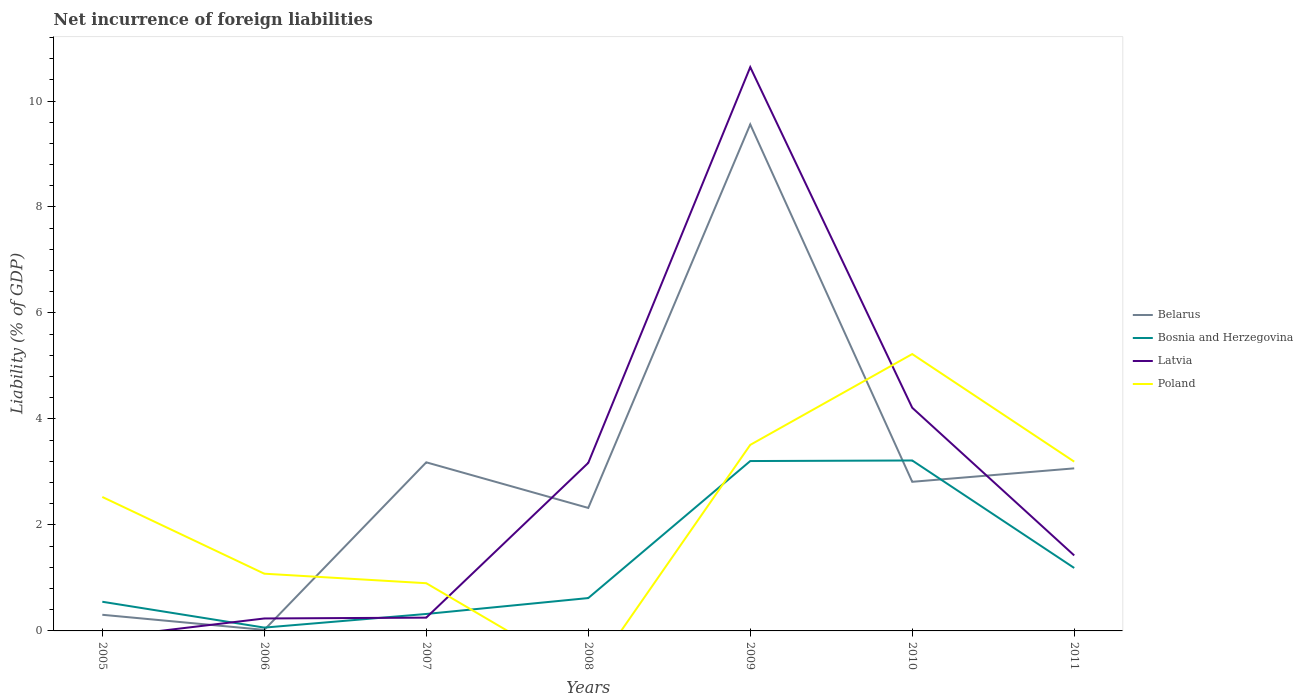How many different coloured lines are there?
Your answer should be compact. 4. Is the number of lines equal to the number of legend labels?
Keep it short and to the point. No. What is the total net incurrence of foreign liabilities in Poland in the graph?
Give a very brief answer. -0.98. What is the difference between the highest and the second highest net incurrence of foreign liabilities in Bosnia and Herzegovina?
Your response must be concise. 3.15. What is the difference between the highest and the lowest net incurrence of foreign liabilities in Poland?
Make the answer very short. 4. How many lines are there?
Provide a succinct answer. 4. What is the difference between two consecutive major ticks on the Y-axis?
Offer a very short reply. 2. Does the graph contain any zero values?
Provide a short and direct response. Yes. Where does the legend appear in the graph?
Your answer should be compact. Center right. How many legend labels are there?
Provide a short and direct response. 4. How are the legend labels stacked?
Your answer should be very brief. Vertical. What is the title of the graph?
Offer a very short reply. Net incurrence of foreign liabilities. What is the label or title of the X-axis?
Keep it short and to the point. Years. What is the label or title of the Y-axis?
Provide a succinct answer. Liability (% of GDP). What is the Liability (% of GDP) of Belarus in 2005?
Ensure brevity in your answer.  0.3. What is the Liability (% of GDP) in Bosnia and Herzegovina in 2005?
Your answer should be compact. 0.55. What is the Liability (% of GDP) in Latvia in 2005?
Your answer should be compact. 0. What is the Liability (% of GDP) in Poland in 2005?
Offer a very short reply. 2.53. What is the Liability (% of GDP) of Belarus in 2006?
Ensure brevity in your answer.  0.02. What is the Liability (% of GDP) in Bosnia and Herzegovina in 2006?
Your answer should be compact. 0.06. What is the Liability (% of GDP) in Latvia in 2006?
Your answer should be very brief. 0.23. What is the Liability (% of GDP) of Poland in 2006?
Ensure brevity in your answer.  1.08. What is the Liability (% of GDP) in Belarus in 2007?
Make the answer very short. 3.18. What is the Liability (% of GDP) of Bosnia and Herzegovina in 2007?
Give a very brief answer. 0.32. What is the Liability (% of GDP) of Latvia in 2007?
Make the answer very short. 0.25. What is the Liability (% of GDP) of Poland in 2007?
Keep it short and to the point. 0.9. What is the Liability (% of GDP) of Belarus in 2008?
Your answer should be compact. 2.32. What is the Liability (% of GDP) of Bosnia and Herzegovina in 2008?
Provide a short and direct response. 0.62. What is the Liability (% of GDP) in Latvia in 2008?
Provide a succinct answer. 3.17. What is the Liability (% of GDP) in Poland in 2008?
Give a very brief answer. 0. What is the Liability (% of GDP) of Belarus in 2009?
Keep it short and to the point. 9.56. What is the Liability (% of GDP) of Bosnia and Herzegovina in 2009?
Offer a very short reply. 3.21. What is the Liability (% of GDP) of Latvia in 2009?
Keep it short and to the point. 10.64. What is the Liability (% of GDP) of Poland in 2009?
Provide a short and direct response. 3.51. What is the Liability (% of GDP) of Belarus in 2010?
Offer a very short reply. 2.81. What is the Liability (% of GDP) in Bosnia and Herzegovina in 2010?
Provide a succinct answer. 3.22. What is the Liability (% of GDP) of Latvia in 2010?
Keep it short and to the point. 4.21. What is the Liability (% of GDP) of Poland in 2010?
Ensure brevity in your answer.  5.22. What is the Liability (% of GDP) of Belarus in 2011?
Your answer should be very brief. 3.07. What is the Liability (% of GDP) in Bosnia and Herzegovina in 2011?
Provide a short and direct response. 1.19. What is the Liability (% of GDP) of Latvia in 2011?
Offer a very short reply. 1.42. What is the Liability (% of GDP) of Poland in 2011?
Keep it short and to the point. 3.19. Across all years, what is the maximum Liability (% of GDP) of Belarus?
Your response must be concise. 9.56. Across all years, what is the maximum Liability (% of GDP) in Bosnia and Herzegovina?
Your answer should be very brief. 3.22. Across all years, what is the maximum Liability (% of GDP) of Latvia?
Provide a short and direct response. 10.64. Across all years, what is the maximum Liability (% of GDP) in Poland?
Provide a succinct answer. 5.22. Across all years, what is the minimum Liability (% of GDP) of Belarus?
Make the answer very short. 0.02. Across all years, what is the minimum Liability (% of GDP) of Bosnia and Herzegovina?
Your response must be concise. 0.06. What is the total Liability (% of GDP) in Belarus in the graph?
Your response must be concise. 21.27. What is the total Liability (% of GDP) of Bosnia and Herzegovina in the graph?
Offer a terse response. 9.16. What is the total Liability (% of GDP) in Latvia in the graph?
Your answer should be compact. 19.93. What is the total Liability (% of GDP) in Poland in the graph?
Ensure brevity in your answer.  16.44. What is the difference between the Liability (% of GDP) in Belarus in 2005 and that in 2006?
Provide a succinct answer. 0.28. What is the difference between the Liability (% of GDP) in Bosnia and Herzegovina in 2005 and that in 2006?
Your answer should be compact. 0.49. What is the difference between the Liability (% of GDP) of Poland in 2005 and that in 2006?
Offer a terse response. 1.45. What is the difference between the Liability (% of GDP) in Belarus in 2005 and that in 2007?
Provide a succinct answer. -2.88. What is the difference between the Liability (% of GDP) in Bosnia and Herzegovina in 2005 and that in 2007?
Give a very brief answer. 0.23. What is the difference between the Liability (% of GDP) of Poland in 2005 and that in 2007?
Your answer should be compact. 1.63. What is the difference between the Liability (% of GDP) in Belarus in 2005 and that in 2008?
Offer a terse response. -2.02. What is the difference between the Liability (% of GDP) in Bosnia and Herzegovina in 2005 and that in 2008?
Your answer should be compact. -0.07. What is the difference between the Liability (% of GDP) of Belarus in 2005 and that in 2009?
Your answer should be compact. -9.25. What is the difference between the Liability (% of GDP) in Bosnia and Herzegovina in 2005 and that in 2009?
Your response must be concise. -2.66. What is the difference between the Liability (% of GDP) of Poland in 2005 and that in 2009?
Your answer should be very brief. -0.98. What is the difference between the Liability (% of GDP) of Belarus in 2005 and that in 2010?
Your answer should be compact. -2.51. What is the difference between the Liability (% of GDP) of Bosnia and Herzegovina in 2005 and that in 2010?
Offer a very short reply. -2.67. What is the difference between the Liability (% of GDP) of Poland in 2005 and that in 2010?
Your answer should be compact. -2.7. What is the difference between the Liability (% of GDP) of Belarus in 2005 and that in 2011?
Give a very brief answer. -2.76. What is the difference between the Liability (% of GDP) in Bosnia and Herzegovina in 2005 and that in 2011?
Offer a very short reply. -0.64. What is the difference between the Liability (% of GDP) of Poland in 2005 and that in 2011?
Keep it short and to the point. -0.67. What is the difference between the Liability (% of GDP) in Belarus in 2006 and that in 2007?
Your response must be concise. -3.16. What is the difference between the Liability (% of GDP) of Bosnia and Herzegovina in 2006 and that in 2007?
Provide a short and direct response. -0.26. What is the difference between the Liability (% of GDP) in Latvia in 2006 and that in 2007?
Keep it short and to the point. -0.02. What is the difference between the Liability (% of GDP) of Poland in 2006 and that in 2007?
Offer a terse response. 0.18. What is the difference between the Liability (% of GDP) of Belarus in 2006 and that in 2008?
Keep it short and to the point. -2.3. What is the difference between the Liability (% of GDP) in Bosnia and Herzegovina in 2006 and that in 2008?
Keep it short and to the point. -0.56. What is the difference between the Liability (% of GDP) of Latvia in 2006 and that in 2008?
Give a very brief answer. -2.94. What is the difference between the Liability (% of GDP) of Belarus in 2006 and that in 2009?
Provide a succinct answer. -9.54. What is the difference between the Liability (% of GDP) in Bosnia and Herzegovina in 2006 and that in 2009?
Give a very brief answer. -3.14. What is the difference between the Liability (% of GDP) of Latvia in 2006 and that in 2009?
Provide a short and direct response. -10.4. What is the difference between the Liability (% of GDP) of Poland in 2006 and that in 2009?
Ensure brevity in your answer.  -2.43. What is the difference between the Liability (% of GDP) in Belarus in 2006 and that in 2010?
Provide a succinct answer. -2.79. What is the difference between the Liability (% of GDP) in Bosnia and Herzegovina in 2006 and that in 2010?
Provide a succinct answer. -3.15. What is the difference between the Liability (% of GDP) of Latvia in 2006 and that in 2010?
Make the answer very short. -3.98. What is the difference between the Liability (% of GDP) in Poland in 2006 and that in 2010?
Your answer should be very brief. -4.14. What is the difference between the Liability (% of GDP) in Belarus in 2006 and that in 2011?
Your response must be concise. -3.05. What is the difference between the Liability (% of GDP) in Bosnia and Herzegovina in 2006 and that in 2011?
Your answer should be compact. -1.13. What is the difference between the Liability (% of GDP) of Latvia in 2006 and that in 2011?
Offer a terse response. -1.19. What is the difference between the Liability (% of GDP) in Poland in 2006 and that in 2011?
Offer a terse response. -2.11. What is the difference between the Liability (% of GDP) of Belarus in 2007 and that in 2008?
Provide a short and direct response. 0.86. What is the difference between the Liability (% of GDP) in Bosnia and Herzegovina in 2007 and that in 2008?
Your answer should be very brief. -0.3. What is the difference between the Liability (% of GDP) in Latvia in 2007 and that in 2008?
Your answer should be very brief. -2.92. What is the difference between the Liability (% of GDP) in Belarus in 2007 and that in 2009?
Make the answer very short. -6.38. What is the difference between the Liability (% of GDP) of Bosnia and Herzegovina in 2007 and that in 2009?
Offer a very short reply. -2.89. What is the difference between the Liability (% of GDP) in Latvia in 2007 and that in 2009?
Ensure brevity in your answer.  -10.39. What is the difference between the Liability (% of GDP) in Poland in 2007 and that in 2009?
Offer a terse response. -2.61. What is the difference between the Liability (% of GDP) of Belarus in 2007 and that in 2010?
Offer a terse response. 0.37. What is the difference between the Liability (% of GDP) in Bosnia and Herzegovina in 2007 and that in 2010?
Your answer should be compact. -2.9. What is the difference between the Liability (% of GDP) of Latvia in 2007 and that in 2010?
Keep it short and to the point. -3.96. What is the difference between the Liability (% of GDP) of Poland in 2007 and that in 2010?
Offer a very short reply. -4.32. What is the difference between the Liability (% of GDP) of Belarus in 2007 and that in 2011?
Ensure brevity in your answer.  0.11. What is the difference between the Liability (% of GDP) of Bosnia and Herzegovina in 2007 and that in 2011?
Ensure brevity in your answer.  -0.87. What is the difference between the Liability (% of GDP) in Latvia in 2007 and that in 2011?
Your answer should be very brief. -1.17. What is the difference between the Liability (% of GDP) of Poland in 2007 and that in 2011?
Provide a succinct answer. -2.29. What is the difference between the Liability (% of GDP) of Belarus in 2008 and that in 2009?
Provide a short and direct response. -7.24. What is the difference between the Liability (% of GDP) in Bosnia and Herzegovina in 2008 and that in 2009?
Offer a very short reply. -2.59. What is the difference between the Liability (% of GDP) of Latvia in 2008 and that in 2009?
Give a very brief answer. -7.47. What is the difference between the Liability (% of GDP) of Belarus in 2008 and that in 2010?
Offer a terse response. -0.49. What is the difference between the Liability (% of GDP) in Bosnia and Herzegovina in 2008 and that in 2010?
Make the answer very short. -2.6. What is the difference between the Liability (% of GDP) in Latvia in 2008 and that in 2010?
Your answer should be compact. -1.04. What is the difference between the Liability (% of GDP) of Belarus in 2008 and that in 2011?
Make the answer very short. -0.75. What is the difference between the Liability (% of GDP) of Bosnia and Herzegovina in 2008 and that in 2011?
Your answer should be compact. -0.57. What is the difference between the Liability (% of GDP) in Latvia in 2008 and that in 2011?
Offer a very short reply. 1.75. What is the difference between the Liability (% of GDP) in Belarus in 2009 and that in 2010?
Your answer should be compact. 6.74. What is the difference between the Liability (% of GDP) in Bosnia and Herzegovina in 2009 and that in 2010?
Your answer should be very brief. -0.01. What is the difference between the Liability (% of GDP) of Latvia in 2009 and that in 2010?
Provide a succinct answer. 6.43. What is the difference between the Liability (% of GDP) of Poland in 2009 and that in 2010?
Your response must be concise. -1.71. What is the difference between the Liability (% of GDP) in Belarus in 2009 and that in 2011?
Give a very brief answer. 6.49. What is the difference between the Liability (% of GDP) in Bosnia and Herzegovina in 2009 and that in 2011?
Keep it short and to the point. 2.02. What is the difference between the Liability (% of GDP) in Latvia in 2009 and that in 2011?
Provide a short and direct response. 9.21. What is the difference between the Liability (% of GDP) of Poland in 2009 and that in 2011?
Ensure brevity in your answer.  0.32. What is the difference between the Liability (% of GDP) of Belarus in 2010 and that in 2011?
Provide a succinct answer. -0.25. What is the difference between the Liability (% of GDP) in Bosnia and Herzegovina in 2010 and that in 2011?
Your response must be concise. 2.03. What is the difference between the Liability (% of GDP) in Latvia in 2010 and that in 2011?
Offer a terse response. 2.79. What is the difference between the Liability (% of GDP) of Poland in 2010 and that in 2011?
Your response must be concise. 2.03. What is the difference between the Liability (% of GDP) of Belarus in 2005 and the Liability (% of GDP) of Bosnia and Herzegovina in 2006?
Offer a terse response. 0.24. What is the difference between the Liability (% of GDP) of Belarus in 2005 and the Liability (% of GDP) of Latvia in 2006?
Keep it short and to the point. 0.07. What is the difference between the Liability (% of GDP) of Belarus in 2005 and the Liability (% of GDP) of Poland in 2006?
Offer a very short reply. -0.78. What is the difference between the Liability (% of GDP) of Bosnia and Herzegovina in 2005 and the Liability (% of GDP) of Latvia in 2006?
Provide a short and direct response. 0.32. What is the difference between the Liability (% of GDP) of Bosnia and Herzegovina in 2005 and the Liability (% of GDP) of Poland in 2006?
Your response must be concise. -0.53. What is the difference between the Liability (% of GDP) of Belarus in 2005 and the Liability (% of GDP) of Bosnia and Herzegovina in 2007?
Your response must be concise. -0.02. What is the difference between the Liability (% of GDP) of Belarus in 2005 and the Liability (% of GDP) of Latvia in 2007?
Your answer should be very brief. 0.05. What is the difference between the Liability (% of GDP) in Belarus in 2005 and the Liability (% of GDP) in Poland in 2007?
Ensure brevity in your answer.  -0.6. What is the difference between the Liability (% of GDP) in Bosnia and Herzegovina in 2005 and the Liability (% of GDP) in Latvia in 2007?
Make the answer very short. 0.3. What is the difference between the Liability (% of GDP) in Bosnia and Herzegovina in 2005 and the Liability (% of GDP) in Poland in 2007?
Your response must be concise. -0.35. What is the difference between the Liability (% of GDP) of Belarus in 2005 and the Liability (% of GDP) of Bosnia and Herzegovina in 2008?
Keep it short and to the point. -0.32. What is the difference between the Liability (% of GDP) of Belarus in 2005 and the Liability (% of GDP) of Latvia in 2008?
Keep it short and to the point. -2.87. What is the difference between the Liability (% of GDP) in Bosnia and Herzegovina in 2005 and the Liability (% of GDP) in Latvia in 2008?
Provide a succinct answer. -2.62. What is the difference between the Liability (% of GDP) of Belarus in 2005 and the Liability (% of GDP) of Bosnia and Herzegovina in 2009?
Your answer should be compact. -2.9. What is the difference between the Liability (% of GDP) of Belarus in 2005 and the Liability (% of GDP) of Latvia in 2009?
Give a very brief answer. -10.33. What is the difference between the Liability (% of GDP) of Belarus in 2005 and the Liability (% of GDP) of Poland in 2009?
Give a very brief answer. -3.21. What is the difference between the Liability (% of GDP) in Bosnia and Herzegovina in 2005 and the Liability (% of GDP) in Latvia in 2009?
Provide a succinct answer. -10.09. What is the difference between the Liability (% of GDP) in Bosnia and Herzegovina in 2005 and the Liability (% of GDP) in Poland in 2009?
Keep it short and to the point. -2.96. What is the difference between the Liability (% of GDP) of Belarus in 2005 and the Liability (% of GDP) of Bosnia and Herzegovina in 2010?
Ensure brevity in your answer.  -2.91. What is the difference between the Liability (% of GDP) of Belarus in 2005 and the Liability (% of GDP) of Latvia in 2010?
Offer a terse response. -3.91. What is the difference between the Liability (% of GDP) of Belarus in 2005 and the Liability (% of GDP) of Poland in 2010?
Provide a succinct answer. -4.92. What is the difference between the Liability (% of GDP) in Bosnia and Herzegovina in 2005 and the Liability (% of GDP) in Latvia in 2010?
Your response must be concise. -3.66. What is the difference between the Liability (% of GDP) of Bosnia and Herzegovina in 2005 and the Liability (% of GDP) of Poland in 2010?
Offer a very short reply. -4.67. What is the difference between the Liability (% of GDP) in Belarus in 2005 and the Liability (% of GDP) in Bosnia and Herzegovina in 2011?
Your response must be concise. -0.88. What is the difference between the Liability (% of GDP) in Belarus in 2005 and the Liability (% of GDP) in Latvia in 2011?
Provide a succinct answer. -1.12. What is the difference between the Liability (% of GDP) of Belarus in 2005 and the Liability (% of GDP) of Poland in 2011?
Provide a short and direct response. -2.89. What is the difference between the Liability (% of GDP) in Bosnia and Herzegovina in 2005 and the Liability (% of GDP) in Latvia in 2011?
Provide a succinct answer. -0.87. What is the difference between the Liability (% of GDP) in Bosnia and Herzegovina in 2005 and the Liability (% of GDP) in Poland in 2011?
Provide a succinct answer. -2.64. What is the difference between the Liability (% of GDP) of Belarus in 2006 and the Liability (% of GDP) of Bosnia and Herzegovina in 2007?
Provide a succinct answer. -0.3. What is the difference between the Liability (% of GDP) in Belarus in 2006 and the Liability (% of GDP) in Latvia in 2007?
Provide a succinct answer. -0.23. What is the difference between the Liability (% of GDP) of Belarus in 2006 and the Liability (% of GDP) of Poland in 2007?
Give a very brief answer. -0.88. What is the difference between the Liability (% of GDP) of Bosnia and Herzegovina in 2006 and the Liability (% of GDP) of Latvia in 2007?
Provide a succinct answer. -0.19. What is the difference between the Liability (% of GDP) in Bosnia and Herzegovina in 2006 and the Liability (% of GDP) in Poland in 2007?
Your response must be concise. -0.84. What is the difference between the Liability (% of GDP) in Latvia in 2006 and the Liability (% of GDP) in Poland in 2007?
Make the answer very short. -0.67. What is the difference between the Liability (% of GDP) in Belarus in 2006 and the Liability (% of GDP) in Bosnia and Herzegovina in 2008?
Keep it short and to the point. -0.6. What is the difference between the Liability (% of GDP) of Belarus in 2006 and the Liability (% of GDP) of Latvia in 2008?
Provide a short and direct response. -3.15. What is the difference between the Liability (% of GDP) of Bosnia and Herzegovina in 2006 and the Liability (% of GDP) of Latvia in 2008?
Provide a short and direct response. -3.11. What is the difference between the Liability (% of GDP) in Belarus in 2006 and the Liability (% of GDP) in Bosnia and Herzegovina in 2009?
Make the answer very short. -3.19. What is the difference between the Liability (% of GDP) in Belarus in 2006 and the Liability (% of GDP) in Latvia in 2009?
Provide a short and direct response. -10.62. What is the difference between the Liability (% of GDP) in Belarus in 2006 and the Liability (% of GDP) in Poland in 2009?
Offer a terse response. -3.49. What is the difference between the Liability (% of GDP) of Bosnia and Herzegovina in 2006 and the Liability (% of GDP) of Latvia in 2009?
Offer a very short reply. -10.58. What is the difference between the Liability (% of GDP) in Bosnia and Herzegovina in 2006 and the Liability (% of GDP) in Poland in 2009?
Give a very brief answer. -3.45. What is the difference between the Liability (% of GDP) in Latvia in 2006 and the Liability (% of GDP) in Poland in 2009?
Provide a short and direct response. -3.28. What is the difference between the Liability (% of GDP) of Belarus in 2006 and the Liability (% of GDP) of Bosnia and Herzegovina in 2010?
Ensure brevity in your answer.  -3.2. What is the difference between the Liability (% of GDP) in Belarus in 2006 and the Liability (% of GDP) in Latvia in 2010?
Your answer should be very brief. -4.19. What is the difference between the Liability (% of GDP) of Belarus in 2006 and the Liability (% of GDP) of Poland in 2010?
Offer a very short reply. -5.2. What is the difference between the Liability (% of GDP) of Bosnia and Herzegovina in 2006 and the Liability (% of GDP) of Latvia in 2010?
Your answer should be very brief. -4.15. What is the difference between the Liability (% of GDP) in Bosnia and Herzegovina in 2006 and the Liability (% of GDP) in Poland in 2010?
Provide a short and direct response. -5.16. What is the difference between the Liability (% of GDP) in Latvia in 2006 and the Liability (% of GDP) in Poland in 2010?
Make the answer very short. -4.99. What is the difference between the Liability (% of GDP) in Belarus in 2006 and the Liability (% of GDP) in Bosnia and Herzegovina in 2011?
Offer a very short reply. -1.17. What is the difference between the Liability (% of GDP) in Belarus in 2006 and the Liability (% of GDP) in Latvia in 2011?
Your answer should be very brief. -1.4. What is the difference between the Liability (% of GDP) in Belarus in 2006 and the Liability (% of GDP) in Poland in 2011?
Offer a terse response. -3.17. What is the difference between the Liability (% of GDP) in Bosnia and Herzegovina in 2006 and the Liability (% of GDP) in Latvia in 2011?
Your answer should be compact. -1.36. What is the difference between the Liability (% of GDP) of Bosnia and Herzegovina in 2006 and the Liability (% of GDP) of Poland in 2011?
Ensure brevity in your answer.  -3.13. What is the difference between the Liability (% of GDP) of Latvia in 2006 and the Liability (% of GDP) of Poland in 2011?
Offer a terse response. -2.96. What is the difference between the Liability (% of GDP) in Belarus in 2007 and the Liability (% of GDP) in Bosnia and Herzegovina in 2008?
Make the answer very short. 2.56. What is the difference between the Liability (% of GDP) in Belarus in 2007 and the Liability (% of GDP) in Latvia in 2008?
Offer a very short reply. 0.01. What is the difference between the Liability (% of GDP) of Bosnia and Herzegovina in 2007 and the Liability (% of GDP) of Latvia in 2008?
Give a very brief answer. -2.85. What is the difference between the Liability (% of GDP) in Belarus in 2007 and the Liability (% of GDP) in Bosnia and Herzegovina in 2009?
Provide a succinct answer. -0.02. What is the difference between the Liability (% of GDP) in Belarus in 2007 and the Liability (% of GDP) in Latvia in 2009?
Offer a terse response. -7.46. What is the difference between the Liability (% of GDP) in Belarus in 2007 and the Liability (% of GDP) in Poland in 2009?
Make the answer very short. -0.33. What is the difference between the Liability (% of GDP) in Bosnia and Herzegovina in 2007 and the Liability (% of GDP) in Latvia in 2009?
Give a very brief answer. -10.32. What is the difference between the Liability (% of GDP) in Bosnia and Herzegovina in 2007 and the Liability (% of GDP) in Poland in 2009?
Keep it short and to the point. -3.19. What is the difference between the Liability (% of GDP) of Latvia in 2007 and the Liability (% of GDP) of Poland in 2009?
Give a very brief answer. -3.26. What is the difference between the Liability (% of GDP) in Belarus in 2007 and the Liability (% of GDP) in Bosnia and Herzegovina in 2010?
Your answer should be compact. -0.03. What is the difference between the Liability (% of GDP) of Belarus in 2007 and the Liability (% of GDP) of Latvia in 2010?
Your answer should be very brief. -1.03. What is the difference between the Liability (% of GDP) in Belarus in 2007 and the Liability (% of GDP) in Poland in 2010?
Give a very brief answer. -2.04. What is the difference between the Liability (% of GDP) in Bosnia and Herzegovina in 2007 and the Liability (% of GDP) in Latvia in 2010?
Ensure brevity in your answer.  -3.89. What is the difference between the Liability (% of GDP) in Bosnia and Herzegovina in 2007 and the Liability (% of GDP) in Poland in 2010?
Your answer should be very brief. -4.9. What is the difference between the Liability (% of GDP) in Latvia in 2007 and the Liability (% of GDP) in Poland in 2010?
Provide a succinct answer. -4.97. What is the difference between the Liability (% of GDP) of Belarus in 2007 and the Liability (% of GDP) of Bosnia and Herzegovina in 2011?
Offer a very short reply. 1.99. What is the difference between the Liability (% of GDP) of Belarus in 2007 and the Liability (% of GDP) of Latvia in 2011?
Offer a terse response. 1.76. What is the difference between the Liability (% of GDP) of Belarus in 2007 and the Liability (% of GDP) of Poland in 2011?
Offer a terse response. -0.01. What is the difference between the Liability (% of GDP) of Bosnia and Herzegovina in 2007 and the Liability (% of GDP) of Latvia in 2011?
Your response must be concise. -1.1. What is the difference between the Liability (% of GDP) in Bosnia and Herzegovina in 2007 and the Liability (% of GDP) in Poland in 2011?
Offer a very short reply. -2.87. What is the difference between the Liability (% of GDP) of Latvia in 2007 and the Liability (% of GDP) of Poland in 2011?
Your response must be concise. -2.94. What is the difference between the Liability (% of GDP) of Belarus in 2008 and the Liability (% of GDP) of Bosnia and Herzegovina in 2009?
Provide a succinct answer. -0.88. What is the difference between the Liability (% of GDP) in Belarus in 2008 and the Liability (% of GDP) in Latvia in 2009?
Keep it short and to the point. -8.32. What is the difference between the Liability (% of GDP) of Belarus in 2008 and the Liability (% of GDP) of Poland in 2009?
Provide a short and direct response. -1.19. What is the difference between the Liability (% of GDP) in Bosnia and Herzegovina in 2008 and the Liability (% of GDP) in Latvia in 2009?
Provide a succinct answer. -10.02. What is the difference between the Liability (% of GDP) in Bosnia and Herzegovina in 2008 and the Liability (% of GDP) in Poland in 2009?
Provide a succinct answer. -2.89. What is the difference between the Liability (% of GDP) of Latvia in 2008 and the Liability (% of GDP) of Poland in 2009?
Your answer should be very brief. -0.34. What is the difference between the Liability (% of GDP) in Belarus in 2008 and the Liability (% of GDP) in Bosnia and Herzegovina in 2010?
Offer a very short reply. -0.9. What is the difference between the Liability (% of GDP) in Belarus in 2008 and the Liability (% of GDP) in Latvia in 2010?
Provide a succinct answer. -1.89. What is the difference between the Liability (% of GDP) in Belarus in 2008 and the Liability (% of GDP) in Poland in 2010?
Provide a short and direct response. -2.9. What is the difference between the Liability (% of GDP) in Bosnia and Herzegovina in 2008 and the Liability (% of GDP) in Latvia in 2010?
Ensure brevity in your answer.  -3.59. What is the difference between the Liability (% of GDP) in Bosnia and Herzegovina in 2008 and the Liability (% of GDP) in Poland in 2010?
Provide a short and direct response. -4.6. What is the difference between the Liability (% of GDP) of Latvia in 2008 and the Liability (% of GDP) of Poland in 2010?
Your answer should be compact. -2.05. What is the difference between the Liability (% of GDP) of Belarus in 2008 and the Liability (% of GDP) of Bosnia and Herzegovina in 2011?
Provide a succinct answer. 1.13. What is the difference between the Liability (% of GDP) of Belarus in 2008 and the Liability (% of GDP) of Latvia in 2011?
Your response must be concise. 0.9. What is the difference between the Liability (% of GDP) in Belarus in 2008 and the Liability (% of GDP) in Poland in 2011?
Provide a short and direct response. -0.87. What is the difference between the Liability (% of GDP) of Bosnia and Herzegovina in 2008 and the Liability (% of GDP) of Latvia in 2011?
Provide a succinct answer. -0.8. What is the difference between the Liability (% of GDP) of Bosnia and Herzegovina in 2008 and the Liability (% of GDP) of Poland in 2011?
Make the answer very short. -2.57. What is the difference between the Liability (% of GDP) in Latvia in 2008 and the Liability (% of GDP) in Poland in 2011?
Give a very brief answer. -0.02. What is the difference between the Liability (% of GDP) in Belarus in 2009 and the Liability (% of GDP) in Bosnia and Herzegovina in 2010?
Your response must be concise. 6.34. What is the difference between the Liability (% of GDP) of Belarus in 2009 and the Liability (% of GDP) of Latvia in 2010?
Make the answer very short. 5.35. What is the difference between the Liability (% of GDP) of Belarus in 2009 and the Liability (% of GDP) of Poland in 2010?
Your answer should be compact. 4.33. What is the difference between the Liability (% of GDP) in Bosnia and Herzegovina in 2009 and the Liability (% of GDP) in Latvia in 2010?
Make the answer very short. -1.01. What is the difference between the Liability (% of GDP) in Bosnia and Herzegovina in 2009 and the Liability (% of GDP) in Poland in 2010?
Give a very brief answer. -2.02. What is the difference between the Liability (% of GDP) in Latvia in 2009 and the Liability (% of GDP) in Poland in 2010?
Ensure brevity in your answer.  5.41. What is the difference between the Liability (% of GDP) in Belarus in 2009 and the Liability (% of GDP) in Bosnia and Herzegovina in 2011?
Offer a very short reply. 8.37. What is the difference between the Liability (% of GDP) in Belarus in 2009 and the Liability (% of GDP) in Latvia in 2011?
Provide a succinct answer. 8.13. What is the difference between the Liability (% of GDP) in Belarus in 2009 and the Liability (% of GDP) in Poland in 2011?
Your answer should be compact. 6.36. What is the difference between the Liability (% of GDP) of Bosnia and Herzegovina in 2009 and the Liability (% of GDP) of Latvia in 2011?
Your response must be concise. 1.78. What is the difference between the Liability (% of GDP) of Bosnia and Herzegovina in 2009 and the Liability (% of GDP) of Poland in 2011?
Your answer should be very brief. 0.01. What is the difference between the Liability (% of GDP) in Latvia in 2009 and the Liability (% of GDP) in Poland in 2011?
Provide a succinct answer. 7.45. What is the difference between the Liability (% of GDP) in Belarus in 2010 and the Liability (% of GDP) in Bosnia and Herzegovina in 2011?
Make the answer very short. 1.63. What is the difference between the Liability (% of GDP) in Belarus in 2010 and the Liability (% of GDP) in Latvia in 2011?
Ensure brevity in your answer.  1.39. What is the difference between the Liability (% of GDP) in Belarus in 2010 and the Liability (% of GDP) in Poland in 2011?
Ensure brevity in your answer.  -0.38. What is the difference between the Liability (% of GDP) in Bosnia and Herzegovina in 2010 and the Liability (% of GDP) in Latvia in 2011?
Ensure brevity in your answer.  1.79. What is the difference between the Liability (% of GDP) of Bosnia and Herzegovina in 2010 and the Liability (% of GDP) of Poland in 2011?
Ensure brevity in your answer.  0.02. What is the difference between the Liability (% of GDP) in Latvia in 2010 and the Liability (% of GDP) in Poland in 2011?
Offer a very short reply. 1.02. What is the average Liability (% of GDP) in Belarus per year?
Your response must be concise. 3.04. What is the average Liability (% of GDP) in Bosnia and Herzegovina per year?
Provide a short and direct response. 1.31. What is the average Liability (% of GDP) of Latvia per year?
Provide a succinct answer. 2.85. What is the average Liability (% of GDP) of Poland per year?
Provide a short and direct response. 2.35. In the year 2005, what is the difference between the Liability (% of GDP) in Belarus and Liability (% of GDP) in Bosnia and Herzegovina?
Make the answer very short. -0.25. In the year 2005, what is the difference between the Liability (% of GDP) of Belarus and Liability (% of GDP) of Poland?
Make the answer very short. -2.22. In the year 2005, what is the difference between the Liability (% of GDP) of Bosnia and Herzegovina and Liability (% of GDP) of Poland?
Offer a very short reply. -1.98. In the year 2006, what is the difference between the Liability (% of GDP) of Belarus and Liability (% of GDP) of Bosnia and Herzegovina?
Make the answer very short. -0.04. In the year 2006, what is the difference between the Liability (% of GDP) of Belarus and Liability (% of GDP) of Latvia?
Provide a succinct answer. -0.22. In the year 2006, what is the difference between the Liability (% of GDP) in Belarus and Liability (% of GDP) in Poland?
Your answer should be very brief. -1.06. In the year 2006, what is the difference between the Liability (% of GDP) of Bosnia and Herzegovina and Liability (% of GDP) of Latvia?
Ensure brevity in your answer.  -0.17. In the year 2006, what is the difference between the Liability (% of GDP) in Bosnia and Herzegovina and Liability (% of GDP) in Poland?
Your answer should be compact. -1.02. In the year 2006, what is the difference between the Liability (% of GDP) of Latvia and Liability (% of GDP) of Poland?
Your response must be concise. -0.84. In the year 2007, what is the difference between the Liability (% of GDP) of Belarus and Liability (% of GDP) of Bosnia and Herzegovina?
Provide a succinct answer. 2.86. In the year 2007, what is the difference between the Liability (% of GDP) in Belarus and Liability (% of GDP) in Latvia?
Give a very brief answer. 2.93. In the year 2007, what is the difference between the Liability (% of GDP) of Belarus and Liability (% of GDP) of Poland?
Your answer should be very brief. 2.28. In the year 2007, what is the difference between the Liability (% of GDP) of Bosnia and Herzegovina and Liability (% of GDP) of Latvia?
Ensure brevity in your answer.  0.07. In the year 2007, what is the difference between the Liability (% of GDP) of Bosnia and Herzegovina and Liability (% of GDP) of Poland?
Ensure brevity in your answer.  -0.58. In the year 2007, what is the difference between the Liability (% of GDP) of Latvia and Liability (% of GDP) of Poland?
Ensure brevity in your answer.  -0.65. In the year 2008, what is the difference between the Liability (% of GDP) in Belarus and Liability (% of GDP) in Bosnia and Herzegovina?
Keep it short and to the point. 1.7. In the year 2008, what is the difference between the Liability (% of GDP) of Belarus and Liability (% of GDP) of Latvia?
Your answer should be very brief. -0.85. In the year 2008, what is the difference between the Liability (% of GDP) of Bosnia and Herzegovina and Liability (% of GDP) of Latvia?
Give a very brief answer. -2.55. In the year 2009, what is the difference between the Liability (% of GDP) of Belarus and Liability (% of GDP) of Bosnia and Herzegovina?
Make the answer very short. 6.35. In the year 2009, what is the difference between the Liability (% of GDP) of Belarus and Liability (% of GDP) of Latvia?
Your answer should be very brief. -1.08. In the year 2009, what is the difference between the Liability (% of GDP) in Belarus and Liability (% of GDP) in Poland?
Give a very brief answer. 6.05. In the year 2009, what is the difference between the Liability (% of GDP) in Bosnia and Herzegovina and Liability (% of GDP) in Latvia?
Offer a very short reply. -7.43. In the year 2009, what is the difference between the Liability (% of GDP) of Bosnia and Herzegovina and Liability (% of GDP) of Poland?
Provide a short and direct response. -0.3. In the year 2009, what is the difference between the Liability (% of GDP) in Latvia and Liability (% of GDP) in Poland?
Your answer should be compact. 7.13. In the year 2010, what is the difference between the Liability (% of GDP) of Belarus and Liability (% of GDP) of Bosnia and Herzegovina?
Offer a very short reply. -0.4. In the year 2010, what is the difference between the Liability (% of GDP) of Belarus and Liability (% of GDP) of Latvia?
Give a very brief answer. -1.4. In the year 2010, what is the difference between the Liability (% of GDP) of Belarus and Liability (% of GDP) of Poland?
Provide a succinct answer. -2.41. In the year 2010, what is the difference between the Liability (% of GDP) of Bosnia and Herzegovina and Liability (% of GDP) of Latvia?
Offer a terse response. -1. In the year 2010, what is the difference between the Liability (% of GDP) in Bosnia and Herzegovina and Liability (% of GDP) in Poland?
Your answer should be compact. -2.01. In the year 2010, what is the difference between the Liability (% of GDP) of Latvia and Liability (% of GDP) of Poland?
Offer a very short reply. -1.01. In the year 2011, what is the difference between the Liability (% of GDP) in Belarus and Liability (% of GDP) in Bosnia and Herzegovina?
Give a very brief answer. 1.88. In the year 2011, what is the difference between the Liability (% of GDP) in Belarus and Liability (% of GDP) in Latvia?
Ensure brevity in your answer.  1.64. In the year 2011, what is the difference between the Liability (% of GDP) in Belarus and Liability (% of GDP) in Poland?
Offer a terse response. -0.13. In the year 2011, what is the difference between the Liability (% of GDP) in Bosnia and Herzegovina and Liability (% of GDP) in Latvia?
Provide a succinct answer. -0.24. In the year 2011, what is the difference between the Liability (% of GDP) in Bosnia and Herzegovina and Liability (% of GDP) in Poland?
Your answer should be compact. -2.01. In the year 2011, what is the difference between the Liability (% of GDP) of Latvia and Liability (% of GDP) of Poland?
Offer a very short reply. -1.77. What is the ratio of the Liability (% of GDP) in Belarus in 2005 to that in 2006?
Make the answer very short. 15.39. What is the ratio of the Liability (% of GDP) of Bosnia and Herzegovina in 2005 to that in 2006?
Give a very brief answer. 8.79. What is the ratio of the Liability (% of GDP) of Poland in 2005 to that in 2006?
Give a very brief answer. 2.34. What is the ratio of the Liability (% of GDP) in Belarus in 2005 to that in 2007?
Offer a very short reply. 0.1. What is the ratio of the Liability (% of GDP) of Bosnia and Herzegovina in 2005 to that in 2007?
Keep it short and to the point. 1.72. What is the ratio of the Liability (% of GDP) of Poland in 2005 to that in 2007?
Your answer should be very brief. 2.81. What is the ratio of the Liability (% of GDP) of Belarus in 2005 to that in 2008?
Keep it short and to the point. 0.13. What is the ratio of the Liability (% of GDP) in Bosnia and Herzegovina in 2005 to that in 2008?
Give a very brief answer. 0.89. What is the ratio of the Liability (% of GDP) in Belarus in 2005 to that in 2009?
Ensure brevity in your answer.  0.03. What is the ratio of the Liability (% of GDP) of Bosnia and Herzegovina in 2005 to that in 2009?
Your answer should be compact. 0.17. What is the ratio of the Liability (% of GDP) of Poland in 2005 to that in 2009?
Ensure brevity in your answer.  0.72. What is the ratio of the Liability (% of GDP) in Belarus in 2005 to that in 2010?
Offer a terse response. 0.11. What is the ratio of the Liability (% of GDP) in Bosnia and Herzegovina in 2005 to that in 2010?
Offer a very short reply. 0.17. What is the ratio of the Liability (% of GDP) in Poland in 2005 to that in 2010?
Your response must be concise. 0.48. What is the ratio of the Liability (% of GDP) in Belarus in 2005 to that in 2011?
Your answer should be very brief. 0.1. What is the ratio of the Liability (% of GDP) in Bosnia and Herzegovina in 2005 to that in 2011?
Provide a succinct answer. 0.46. What is the ratio of the Liability (% of GDP) of Poland in 2005 to that in 2011?
Offer a very short reply. 0.79. What is the ratio of the Liability (% of GDP) of Belarus in 2006 to that in 2007?
Keep it short and to the point. 0.01. What is the ratio of the Liability (% of GDP) of Bosnia and Herzegovina in 2006 to that in 2007?
Offer a very short reply. 0.2. What is the ratio of the Liability (% of GDP) in Latvia in 2006 to that in 2007?
Offer a terse response. 0.94. What is the ratio of the Liability (% of GDP) in Poland in 2006 to that in 2007?
Your response must be concise. 1.2. What is the ratio of the Liability (% of GDP) in Belarus in 2006 to that in 2008?
Ensure brevity in your answer.  0.01. What is the ratio of the Liability (% of GDP) in Bosnia and Herzegovina in 2006 to that in 2008?
Provide a short and direct response. 0.1. What is the ratio of the Liability (% of GDP) of Latvia in 2006 to that in 2008?
Ensure brevity in your answer.  0.07. What is the ratio of the Liability (% of GDP) of Belarus in 2006 to that in 2009?
Offer a terse response. 0. What is the ratio of the Liability (% of GDP) in Bosnia and Herzegovina in 2006 to that in 2009?
Make the answer very short. 0.02. What is the ratio of the Liability (% of GDP) in Latvia in 2006 to that in 2009?
Offer a very short reply. 0.02. What is the ratio of the Liability (% of GDP) in Poland in 2006 to that in 2009?
Your answer should be very brief. 0.31. What is the ratio of the Liability (% of GDP) of Belarus in 2006 to that in 2010?
Make the answer very short. 0.01. What is the ratio of the Liability (% of GDP) of Bosnia and Herzegovina in 2006 to that in 2010?
Offer a very short reply. 0.02. What is the ratio of the Liability (% of GDP) in Latvia in 2006 to that in 2010?
Keep it short and to the point. 0.06. What is the ratio of the Liability (% of GDP) in Poland in 2006 to that in 2010?
Offer a very short reply. 0.21. What is the ratio of the Liability (% of GDP) of Belarus in 2006 to that in 2011?
Your answer should be compact. 0.01. What is the ratio of the Liability (% of GDP) in Bosnia and Herzegovina in 2006 to that in 2011?
Your response must be concise. 0.05. What is the ratio of the Liability (% of GDP) in Latvia in 2006 to that in 2011?
Offer a very short reply. 0.16. What is the ratio of the Liability (% of GDP) of Poland in 2006 to that in 2011?
Your answer should be compact. 0.34. What is the ratio of the Liability (% of GDP) of Belarus in 2007 to that in 2008?
Your answer should be compact. 1.37. What is the ratio of the Liability (% of GDP) of Bosnia and Herzegovina in 2007 to that in 2008?
Provide a succinct answer. 0.52. What is the ratio of the Liability (% of GDP) of Latvia in 2007 to that in 2008?
Make the answer very short. 0.08. What is the ratio of the Liability (% of GDP) of Belarus in 2007 to that in 2009?
Your answer should be compact. 0.33. What is the ratio of the Liability (% of GDP) of Bosnia and Herzegovina in 2007 to that in 2009?
Offer a terse response. 0.1. What is the ratio of the Liability (% of GDP) in Latvia in 2007 to that in 2009?
Offer a very short reply. 0.02. What is the ratio of the Liability (% of GDP) in Poland in 2007 to that in 2009?
Your answer should be compact. 0.26. What is the ratio of the Liability (% of GDP) of Belarus in 2007 to that in 2010?
Your answer should be compact. 1.13. What is the ratio of the Liability (% of GDP) of Bosnia and Herzegovina in 2007 to that in 2010?
Provide a succinct answer. 0.1. What is the ratio of the Liability (% of GDP) in Latvia in 2007 to that in 2010?
Keep it short and to the point. 0.06. What is the ratio of the Liability (% of GDP) in Poland in 2007 to that in 2010?
Provide a short and direct response. 0.17. What is the ratio of the Liability (% of GDP) in Belarus in 2007 to that in 2011?
Make the answer very short. 1.04. What is the ratio of the Liability (% of GDP) of Bosnia and Herzegovina in 2007 to that in 2011?
Provide a succinct answer. 0.27. What is the ratio of the Liability (% of GDP) in Latvia in 2007 to that in 2011?
Your answer should be very brief. 0.18. What is the ratio of the Liability (% of GDP) in Poland in 2007 to that in 2011?
Your answer should be compact. 0.28. What is the ratio of the Liability (% of GDP) in Belarus in 2008 to that in 2009?
Provide a succinct answer. 0.24. What is the ratio of the Liability (% of GDP) in Bosnia and Herzegovina in 2008 to that in 2009?
Your answer should be compact. 0.19. What is the ratio of the Liability (% of GDP) of Latvia in 2008 to that in 2009?
Keep it short and to the point. 0.3. What is the ratio of the Liability (% of GDP) in Belarus in 2008 to that in 2010?
Offer a terse response. 0.82. What is the ratio of the Liability (% of GDP) of Bosnia and Herzegovina in 2008 to that in 2010?
Offer a terse response. 0.19. What is the ratio of the Liability (% of GDP) in Latvia in 2008 to that in 2010?
Your answer should be compact. 0.75. What is the ratio of the Liability (% of GDP) in Belarus in 2008 to that in 2011?
Your answer should be very brief. 0.76. What is the ratio of the Liability (% of GDP) of Bosnia and Herzegovina in 2008 to that in 2011?
Your answer should be compact. 0.52. What is the ratio of the Liability (% of GDP) in Latvia in 2008 to that in 2011?
Your response must be concise. 2.23. What is the ratio of the Liability (% of GDP) in Belarus in 2009 to that in 2010?
Provide a short and direct response. 3.4. What is the ratio of the Liability (% of GDP) in Latvia in 2009 to that in 2010?
Provide a short and direct response. 2.53. What is the ratio of the Liability (% of GDP) of Poland in 2009 to that in 2010?
Your answer should be compact. 0.67. What is the ratio of the Liability (% of GDP) in Belarus in 2009 to that in 2011?
Your answer should be compact. 3.12. What is the ratio of the Liability (% of GDP) of Bosnia and Herzegovina in 2009 to that in 2011?
Offer a very short reply. 2.7. What is the ratio of the Liability (% of GDP) of Latvia in 2009 to that in 2011?
Provide a succinct answer. 7.47. What is the ratio of the Liability (% of GDP) of Poland in 2009 to that in 2011?
Your answer should be very brief. 1.1. What is the ratio of the Liability (% of GDP) of Belarus in 2010 to that in 2011?
Provide a succinct answer. 0.92. What is the ratio of the Liability (% of GDP) in Bosnia and Herzegovina in 2010 to that in 2011?
Offer a very short reply. 2.71. What is the ratio of the Liability (% of GDP) in Latvia in 2010 to that in 2011?
Provide a succinct answer. 2.96. What is the ratio of the Liability (% of GDP) in Poland in 2010 to that in 2011?
Provide a short and direct response. 1.64. What is the difference between the highest and the second highest Liability (% of GDP) in Belarus?
Give a very brief answer. 6.38. What is the difference between the highest and the second highest Liability (% of GDP) of Bosnia and Herzegovina?
Your answer should be very brief. 0.01. What is the difference between the highest and the second highest Liability (% of GDP) in Latvia?
Make the answer very short. 6.43. What is the difference between the highest and the second highest Liability (% of GDP) of Poland?
Offer a very short reply. 1.71. What is the difference between the highest and the lowest Liability (% of GDP) of Belarus?
Provide a succinct answer. 9.54. What is the difference between the highest and the lowest Liability (% of GDP) in Bosnia and Herzegovina?
Provide a short and direct response. 3.15. What is the difference between the highest and the lowest Liability (% of GDP) in Latvia?
Your answer should be compact. 10.64. What is the difference between the highest and the lowest Liability (% of GDP) of Poland?
Provide a short and direct response. 5.22. 